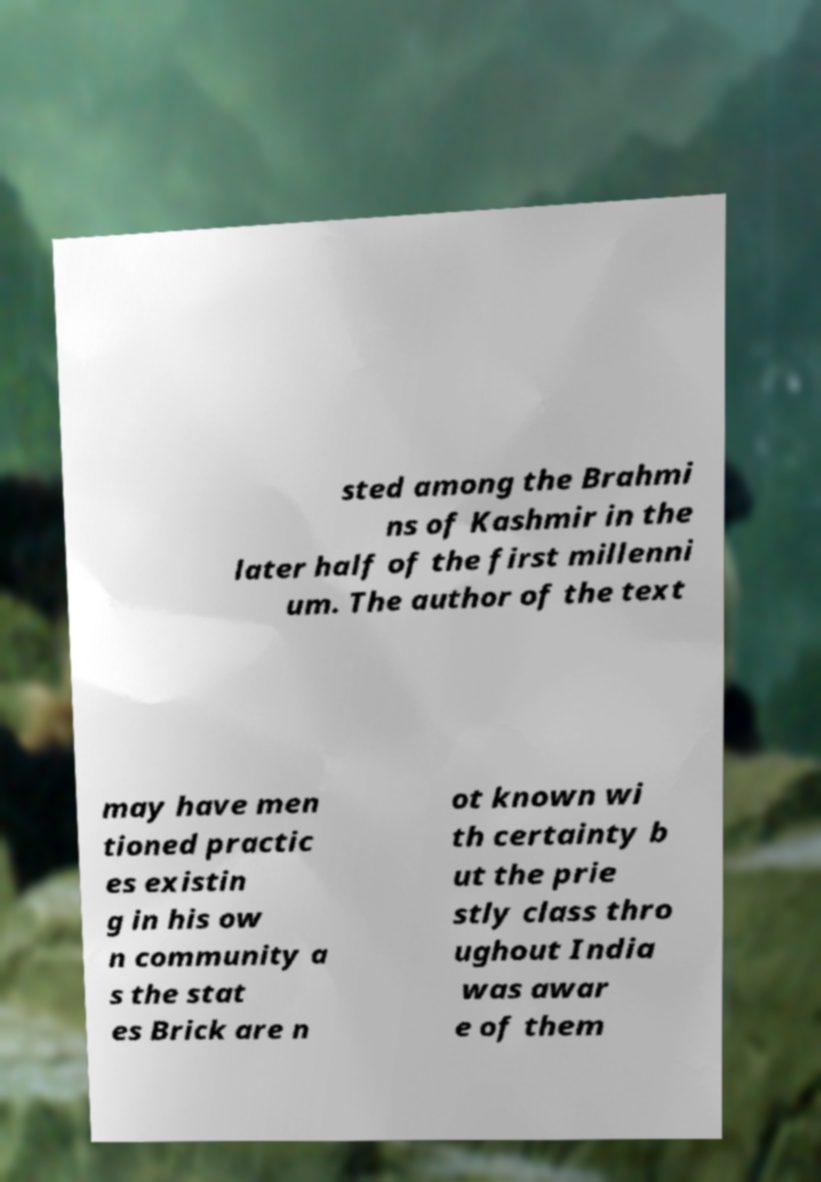Could you extract and type out the text from this image? sted among the Brahmi ns of Kashmir in the later half of the first millenni um. The author of the text may have men tioned practic es existin g in his ow n community a s the stat es Brick are n ot known wi th certainty b ut the prie stly class thro ughout India was awar e of them 